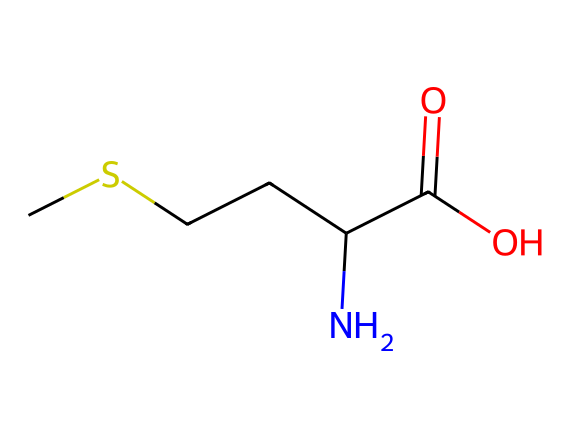What is the molecular formula of methionine? The SMILES representation can be interpreted to derive the molecular formula by counting the atoms of each element present in the structure. From the SMILES, there are 5 carbon (C), 11 hydrogen (H), 1 nitrogen (N), 1 oxygen (O), and 1 sulfur (S) atom. The molecular formula is then C5H11NOS.
Answer: C5H11NOS How many stereocenters are present in methionine? The structure can be assessed for stereocenters by identifying carbon atoms bonded to four different substituents. In methionine, there is one carbon (the alpha carbon next to the amino group) that meets this criterion, indicating one stereocenter.
Answer: 1 What type of functional group is present in methionine? A review of the structure will show various functional groups. Methionine contains both an amino group (NH2) and a carboxylic acid group (COOH), making it an amino acid. However, the presence of the carboxylic group is crucial.
Answer: carboxylic acid What is the role of the sulfur atom in methionine? The sulfur atom in methionine contributes to its classification as an organosulfur compound and is essential for the formation of important biological compounds, such as coenzymes. It also aids in stabilizing protein structure via disulfide bonds.
Answer: organosulfur How does the presence of sulfur affect the properties of methionine? The sulfur atom introduces unique properties, such as increased hydrophobic character and the ability to form disulfide bonds, which affects protein structure and function. The sulfur contributes to the polar and nonpolar attributes of the molecule.
Answer: stabilizes protein structure What would happen to protein synthesis if methionine is not available? Methionine is an essential amino acid required for initiating protein synthesis. Without it, the process cannot begin properly, leading to issues in the production of necessary proteins within the body.
Answer: disrupts protein synthesis 